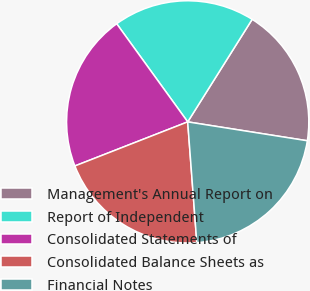Convert chart. <chart><loc_0><loc_0><loc_500><loc_500><pie_chart><fcel>Management's Annual Report on<fcel>Report of Independent<fcel>Consolidated Statements of<fcel>Consolidated Balance Sheets as<fcel>Financial Notes<nl><fcel>18.56%<fcel>18.9%<fcel>20.96%<fcel>20.27%<fcel>21.31%<nl></chart> 